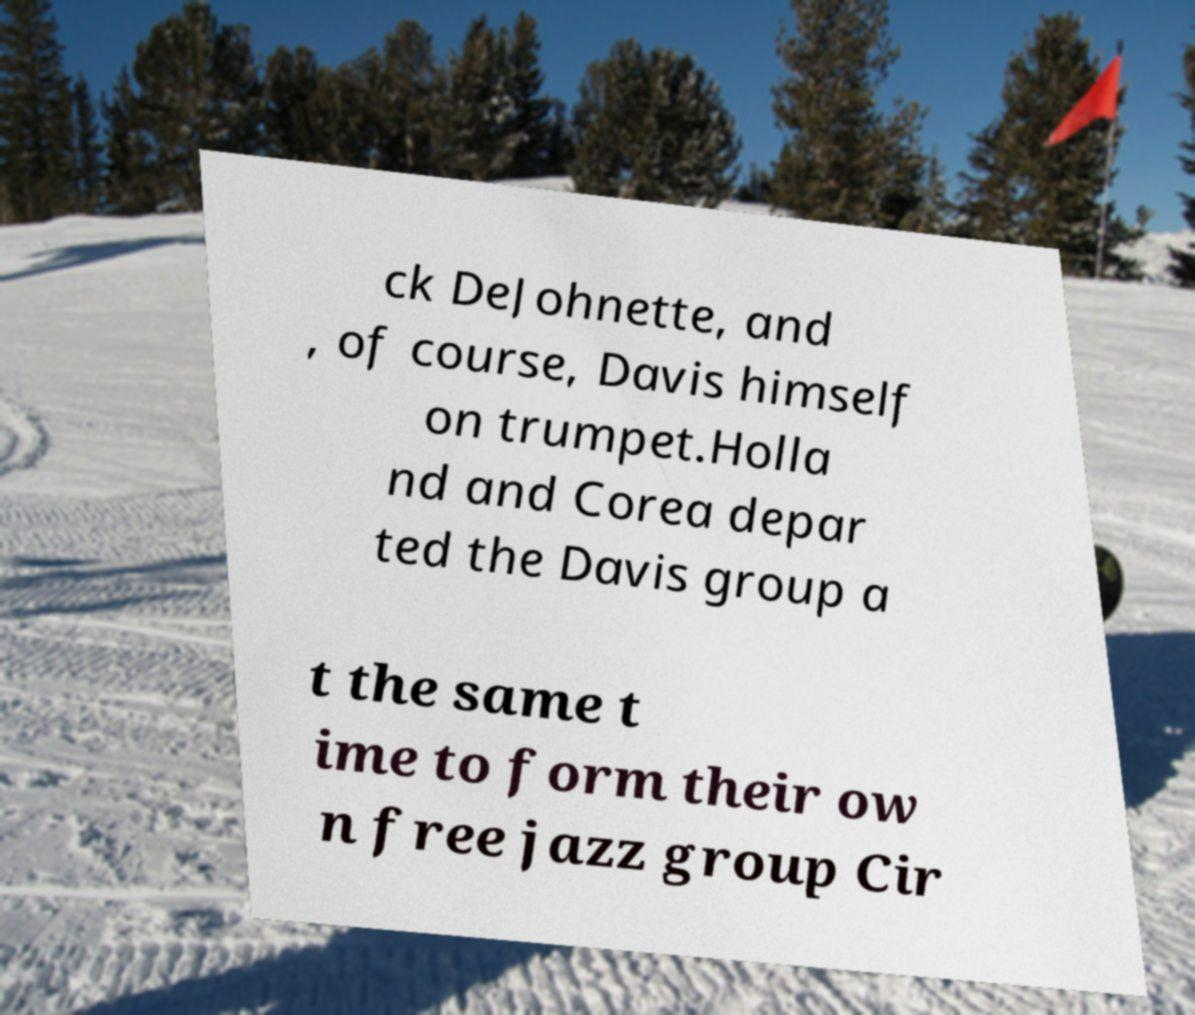What messages or text are displayed in this image? I need them in a readable, typed format. ck DeJohnette, and , of course, Davis himself on trumpet.Holla nd and Corea depar ted the Davis group a t the same t ime to form their ow n free jazz group Cir 